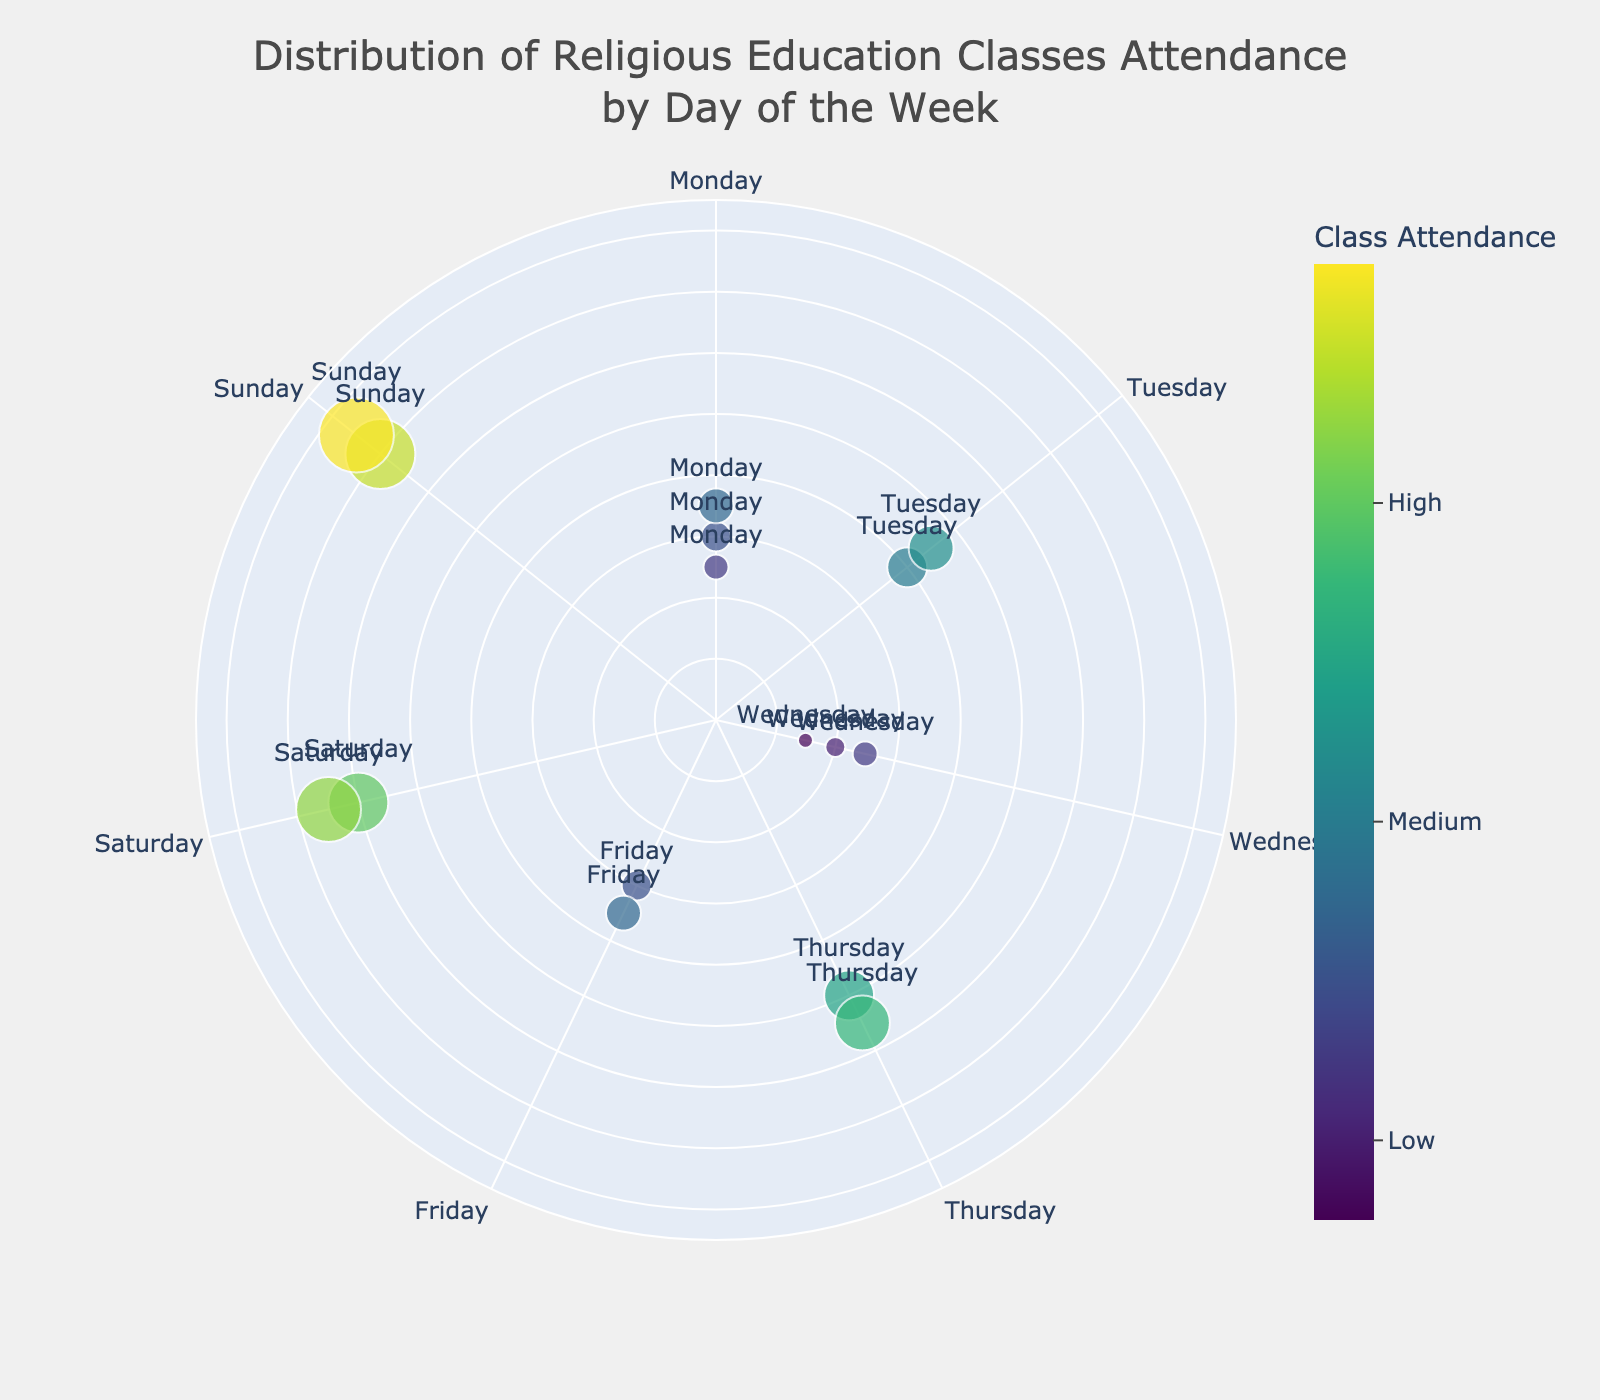What's the highest class attendance on Sunday? To find the highest class attendance on Sunday, look for the markers labeled "Sunday" and identify the highest value. Both markers for Sunday show attendances of 70 and 75, with 75 being the highest.
Answer: 75 What day has the lowest average class attendance? First, identify the attendances for each day, then calculate the average for each day. Monday: (25+30+35)/3 = 30, Tuesday: (40+45)/2 = 42.5, Wednesday: (20+15+25)/3 ≈ 20, Thursday: (50+55)/2 = 52.5, Friday: (30+35)/2 = 32.5, Saturday: (60+65)/2 = 62.5, Sunday: (70+75)/2 = 72.5. Wednesday has the lowest average attendance.
Answer: Wednesday Are there any days with the same highest attendance? Check each day's highest attendance and compare them. Sunday has a highest attendance of 75, which is the highest of all. No other day shares this highest attendance value.
Answer: No Which day has the most consistent range of class attendance values? Calculate the range (difference between maximum and minimum) of class attendances for each day. Monday: 35-25=10, Tuesday: 45-40=5, Wednesday: 25-15=10, Thursday: 55-50=5, Friday: 35-30=5, Saturday: 65-60=5, Sunday: 75-70=5. Days with the smallest range are the most consistent. Tuesday, Thursday, Friday, Saturday, and Sunday all have the same minimum range of 5.
Answer: Tuesday, Thursday, Friday, Saturday, Sunday How does the class attendance on Saturday compare with that on Thursday? Compare the average class attendance for Saturday and Thursday. Thursday's average is (50+55)/2 = 52.5, and Saturday's average is (60+65)/2 = 62.5. Therefore, Saturday has a higher average attendance than Thursday.
Answer: Saturday is higher What is the range of class attendance on Monday? The range is the difference between the highest and lowest attendance on Monday. The highest is 35, and the lowest is 25, so the range is 35 - 25 = 10.
Answer: 10 Which day of the week shows the highest variability in attendance? The day with the highest range in attendance values has the highest variability. Calculate the range for each day: Monday (10), Tuesday (5), Wednesday (10), Thursday (5), Friday (5), Saturday (5), Sunday (5). No day stands out as having more variability than the others; Monday and Wednesday tie with a range of 10.
Answer: Monday, Wednesday What is the average class attendance across all the days? Add all attendance values and divide by the total number of values. (25+30+35+40+45+20+15+25+50+55+30+35+60+65+70+75)/16 = 675/16 = 42.1875.
Answer: 42.19 